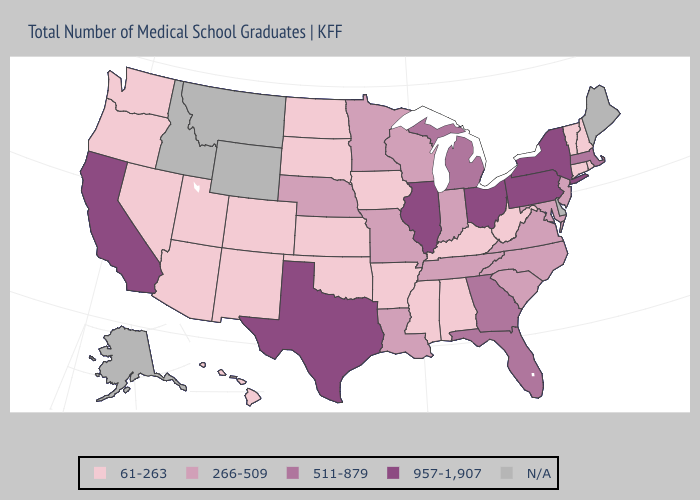Among the states that border Maryland , which have the highest value?
Give a very brief answer. Pennsylvania. Among the states that border Illinois , does Missouri have the highest value?
Concise answer only. Yes. Which states have the lowest value in the USA?
Keep it brief. Alabama, Arizona, Arkansas, Colorado, Connecticut, Hawaii, Iowa, Kansas, Kentucky, Mississippi, Nevada, New Hampshire, New Mexico, North Dakota, Oklahoma, Oregon, Rhode Island, South Dakota, Utah, Vermont, Washington, West Virginia. Which states hav the highest value in the MidWest?
Answer briefly. Illinois, Ohio. Does Rhode Island have the lowest value in the Northeast?
Short answer required. Yes. Name the states that have a value in the range 511-879?
Write a very short answer. Florida, Georgia, Massachusetts, Michigan. Which states have the lowest value in the Northeast?
Concise answer only. Connecticut, New Hampshire, Rhode Island, Vermont. Name the states that have a value in the range 511-879?
Concise answer only. Florida, Georgia, Massachusetts, Michigan. Does the first symbol in the legend represent the smallest category?
Short answer required. Yes. Does Kentucky have the lowest value in the South?
Keep it brief. Yes. Which states have the lowest value in the West?
Write a very short answer. Arizona, Colorado, Hawaii, Nevada, New Mexico, Oregon, Utah, Washington. What is the highest value in the USA?
Quick response, please. 957-1,907. What is the value of Vermont?
Concise answer only. 61-263. Does West Virginia have the lowest value in the South?
Be succinct. Yes. 